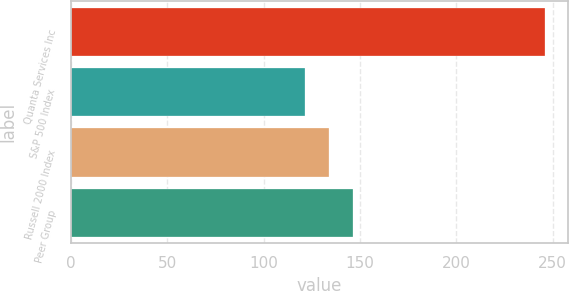Convert chart. <chart><loc_0><loc_0><loc_500><loc_500><bar_chart><fcel>Quanta Services Inc<fcel>S&P 500 Index<fcel>Russell 2000 Index<fcel>Peer Group<nl><fcel>245.88<fcel>121.48<fcel>133.92<fcel>146.36<nl></chart> 